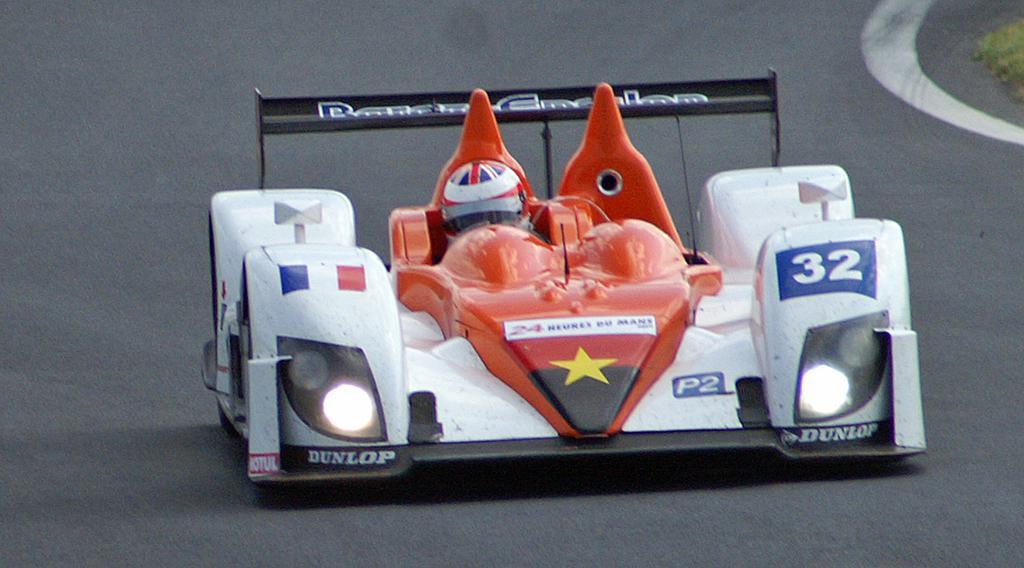In one or two sentences, can you explain what this image depicts? In this image, in the middle, we can see a sports car which is moving on the road. In the car, we can see a man riding it. On the right side, we can see a grass. In the background, we can see road. 